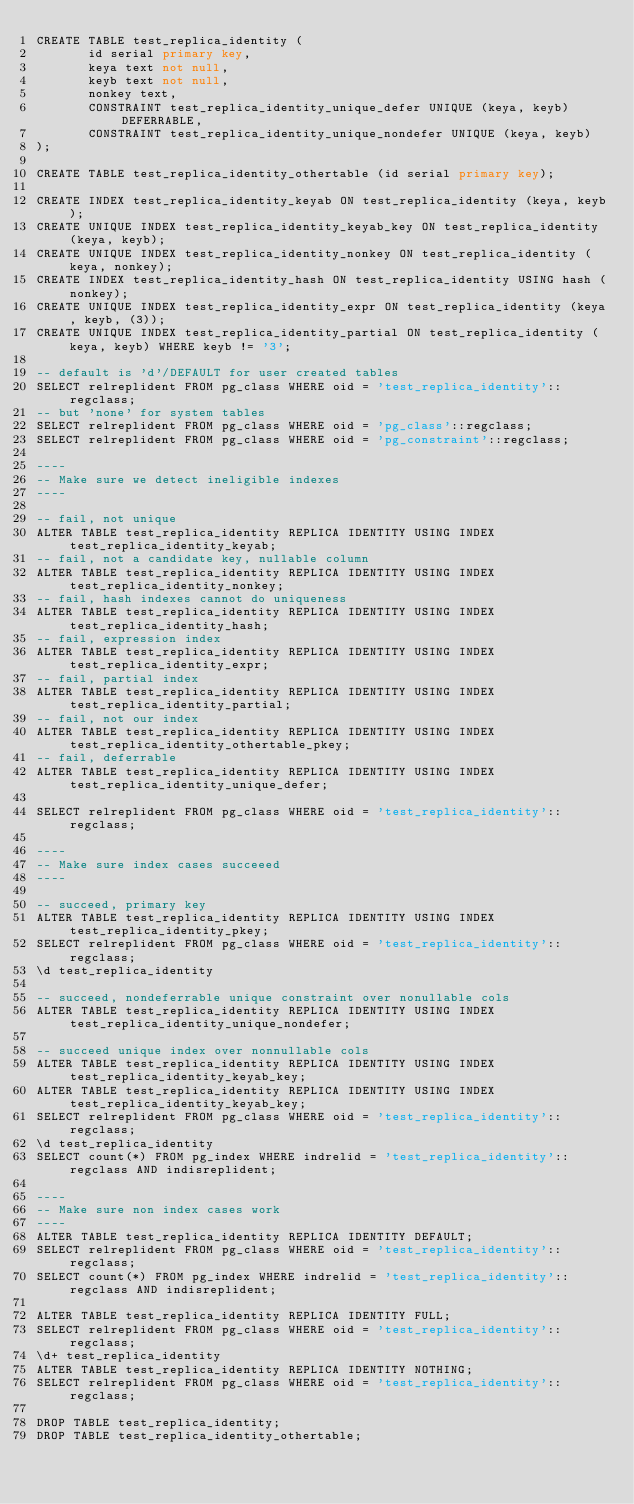<code> <loc_0><loc_0><loc_500><loc_500><_SQL_>CREATE TABLE test_replica_identity (
       id serial primary key,
       keya text not null,
       keyb text not null,
       nonkey text,
       CONSTRAINT test_replica_identity_unique_defer UNIQUE (keya, keyb) DEFERRABLE,
       CONSTRAINT test_replica_identity_unique_nondefer UNIQUE (keya, keyb)
);

CREATE TABLE test_replica_identity_othertable (id serial primary key);

CREATE INDEX test_replica_identity_keyab ON test_replica_identity (keya, keyb);
CREATE UNIQUE INDEX test_replica_identity_keyab_key ON test_replica_identity (keya, keyb);
CREATE UNIQUE INDEX test_replica_identity_nonkey ON test_replica_identity (keya, nonkey);
CREATE INDEX test_replica_identity_hash ON test_replica_identity USING hash (nonkey);
CREATE UNIQUE INDEX test_replica_identity_expr ON test_replica_identity (keya, keyb, (3));
CREATE UNIQUE INDEX test_replica_identity_partial ON test_replica_identity (keya, keyb) WHERE keyb != '3';

-- default is 'd'/DEFAULT for user created tables
SELECT relreplident FROM pg_class WHERE oid = 'test_replica_identity'::regclass;
-- but 'none' for system tables
SELECT relreplident FROM pg_class WHERE oid = 'pg_class'::regclass;
SELECT relreplident FROM pg_class WHERE oid = 'pg_constraint'::regclass;

----
-- Make sure we detect ineligible indexes
----

-- fail, not unique
ALTER TABLE test_replica_identity REPLICA IDENTITY USING INDEX test_replica_identity_keyab;
-- fail, not a candidate key, nullable column
ALTER TABLE test_replica_identity REPLICA IDENTITY USING INDEX test_replica_identity_nonkey;
-- fail, hash indexes cannot do uniqueness
ALTER TABLE test_replica_identity REPLICA IDENTITY USING INDEX test_replica_identity_hash;
-- fail, expression index
ALTER TABLE test_replica_identity REPLICA IDENTITY USING INDEX test_replica_identity_expr;
-- fail, partial index
ALTER TABLE test_replica_identity REPLICA IDENTITY USING INDEX test_replica_identity_partial;
-- fail, not our index
ALTER TABLE test_replica_identity REPLICA IDENTITY USING INDEX test_replica_identity_othertable_pkey;
-- fail, deferrable
ALTER TABLE test_replica_identity REPLICA IDENTITY USING INDEX test_replica_identity_unique_defer;

SELECT relreplident FROM pg_class WHERE oid = 'test_replica_identity'::regclass;

----
-- Make sure index cases succeeed
----

-- succeed, primary key
ALTER TABLE test_replica_identity REPLICA IDENTITY USING INDEX test_replica_identity_pkey;
SELECT relreplident FROM pg_class WHERE oid = 'test_replica_identity'::regclass;
\d test_replica_identity

-- succeed, nondeferrable unique constraint over nonullable cols
ALTER TABLE test_replica_identity REPLICA IDENTITY USING INDEX test_replica_identity_unique_nondefer;

-- succeed unique index over nonnullable cols
ALTER TABLE test_replica_identity REPLICA IDENTITY USING INDEX test_replica_identity_keyab_key;
ALTER TABLE test_replica_identity REPLICA IDENTITY USING INDEX test_replica_identity_keyab_key;
SELECT relreplident FROM pg_class WHERE oid = 'test_replica_identity'::regclass;
\d test_replica_identity
SELECT count(*) FROM pg_index WHERE indrelid = 'test_replica_identity'::regclass AND indisreplident;

----
-- Make sure non index cases work
----
ALTER TABLE test_replica_identity REPLICA IDENTITY DEFAULT;
SELECT relreplident FROM pg_class WHERE oid = 'test_replica_identity'::regclass;
SELECT count(*) FROM pg_index WHERE indrelid = 'test_replica_identity'::regclass AND indisreplident;

ALTER TABLE test_replica_identity REPLICA IDENTITY FULL;
SELECT relreplident FROM pg_class WHERE oid = 'test_replica_identity'::regclass;
\d+ test_replica_identity
ALTER TABLE test_replica_identity REPLICA IDENTITY NOTHING;
SELECT relreplident FROM pg_class WHERE oid = 'test_replica_identity'::regclass;

DROP TABLE test_replica_identity;
DROP TABLE test_replica_identity_othertable;
</code> 